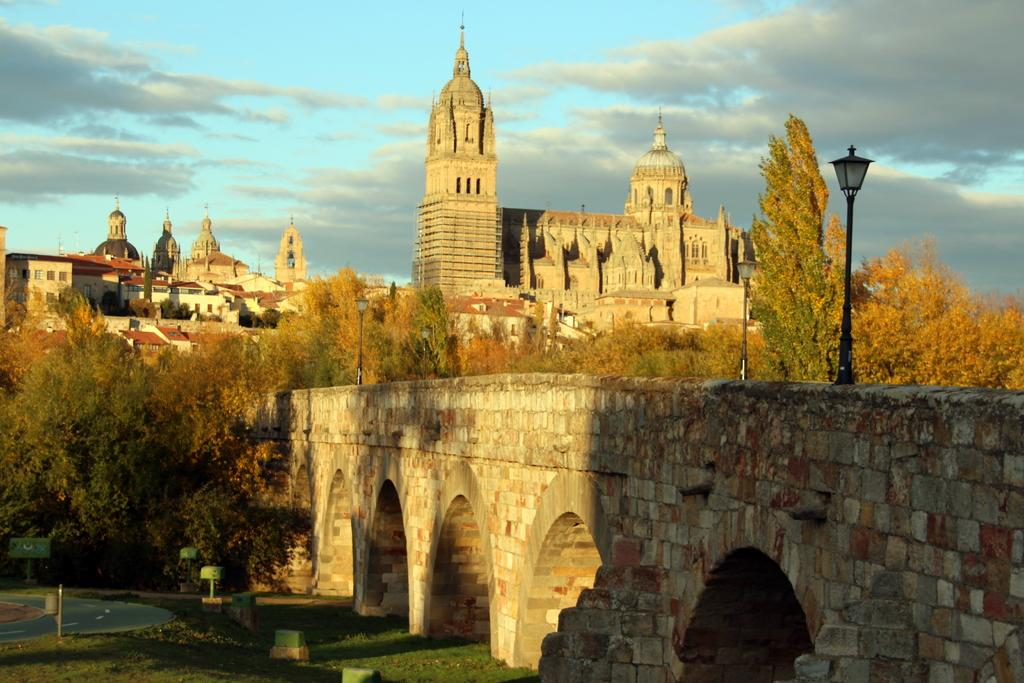What type of structures can be seen in the image? There are buildings in the image. What natural elements are present in the image? There are trees in the image. What man-made objects can be seen in the image? There are poles in the image. What is the main feature in the center of the image? There is a bridge in the center of the image. What type of ground surface is visible at the bottom of the image? There is grass at the bottom of the image. What can be seen in the background of the image? The sky is visible in the background of the image. What type of food is being invented on the bridge in the image? There is no food or invention present in the image; it features buildings, trees, poles, a bridge, grass, and the sky. How does the bridge burn in the image? The bridge does not burn in the image; it is a solid structure. 